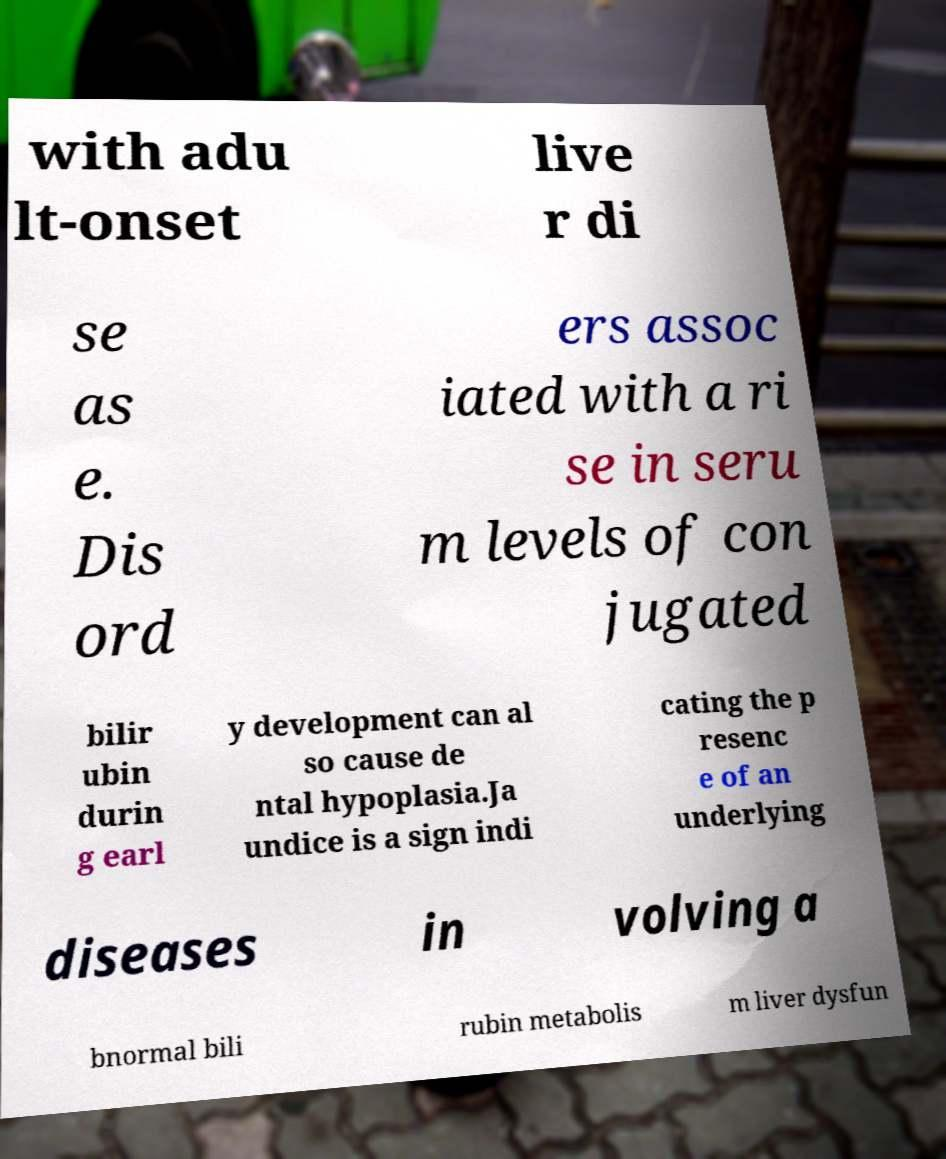Please identify and transcribe the text found in this image. with adu lt-onset live r di se as e. Dis ord ers assoc iated with a ri se in seru m levels of con jugated bilir ubin durin g earl y development can al so cause de ntal hypoplasia.Ja undice is a sign indi cating the p resenc e of an underlying diseases in volving a bnormal bili rubin metabolis m liver dysfun 